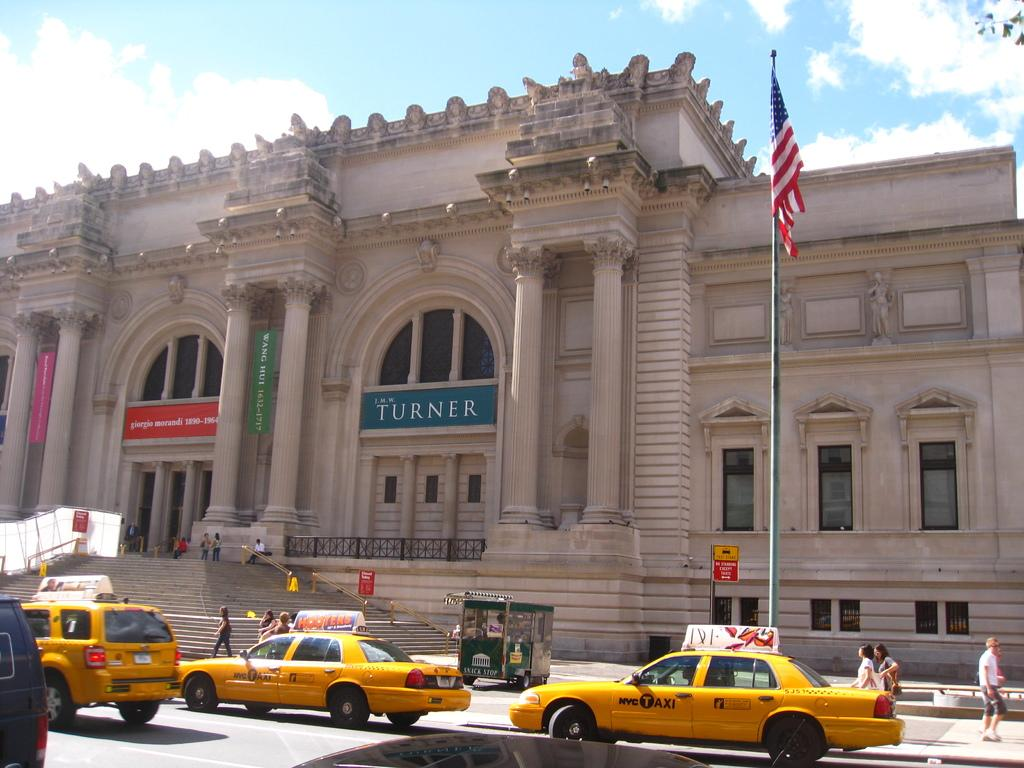<image>
Relay a brief, clear account of the picture shown. lots of taxi cabs on the street and people on the sidewalk 